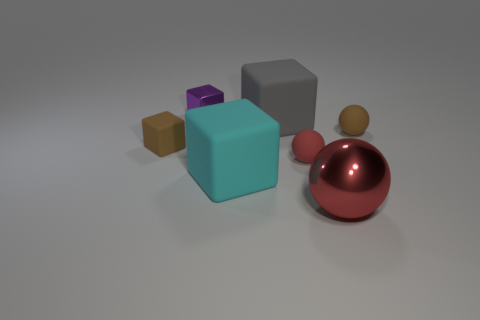What material is the brown object that is on the left side of the tiny purple object left of the large sphere? The brown object on the left side of the tiny purple object appears to be made of a material that resembles rubber. This assumption is based on its matte surface finish and the way it interacts with light, typical of rubber objects in similar visual setups. Note, this is an artistic representation, and the actual material could vary depending on the creator's design. 